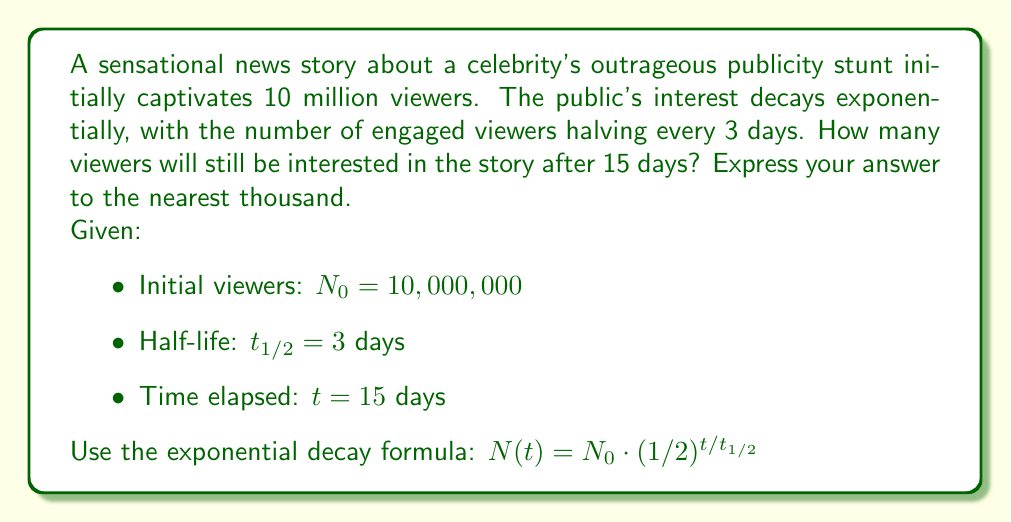Provide a solution to this math problem. To solve this problem, we'll use the exponential decay formula:

$N(t) = N_0 \cdot (1/2)^{t/t_{1/2}}$

Where:
$N(t)$ is the number of viewers at time $t$
$N_0$ is the initial number of viewers
$t$ is the time elapsed
$t_{1/2}$ is the half-life

Step 1: Substitute the given values into the formula
$N(15) = 10,000,000 \cdot (1/2)^{15/3}$

Step 2: Simplify the exponent
$N(15) = 10,000,000 \cdot (1/2)^5$

Step 3: Calculate $(1/2)^5$
$(1/2)^5 = 1/32 = 0.03125$

Step 4: Multiply
$N(15) = 10,000,000 \cdot 0.03125 = 312,500$

Step 5: Round to the nearest thousand
$312,500 \approx 313,000$
Answer: 313,000 viewers 